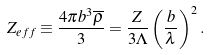Convert formula to latex. <formula><loc_0><loc_0><loc_500><loc_500>Z _ { e f f } \equiv \frac { 4 \pi b ^ { 3 } \overline { \rho } } { 3 } = \frac { Z } { 3 \Lambda } \left ( \frac { b } { \lambda } \right ) ^ { 2 } .</formula> 